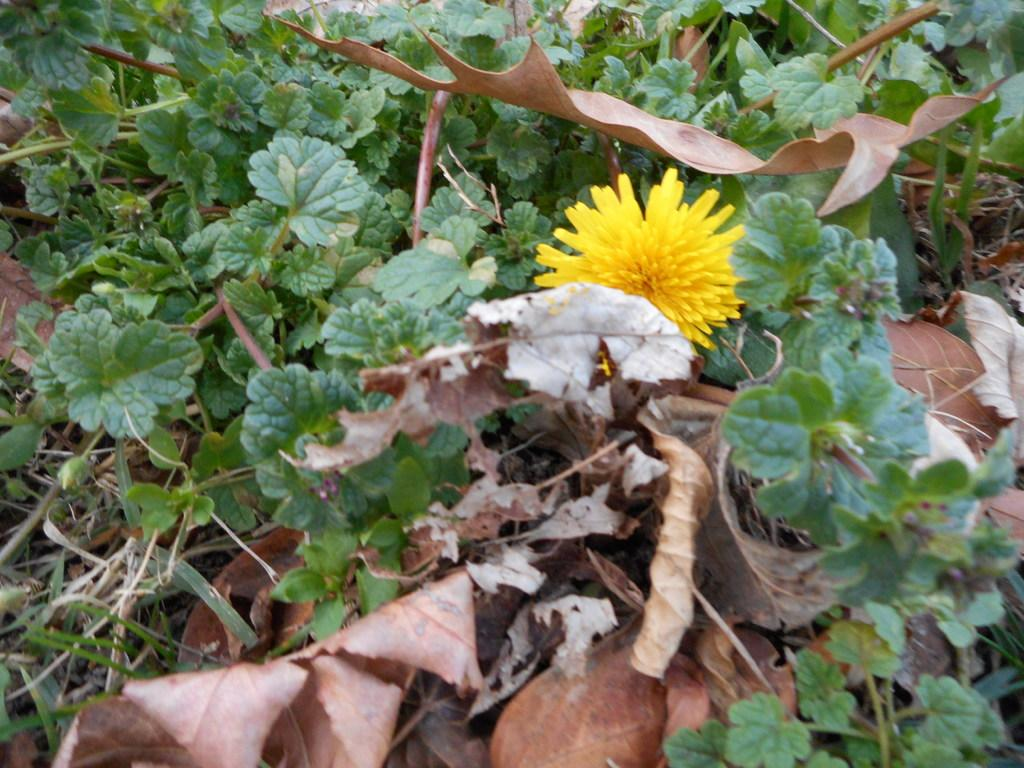What type of living organisms can be seen in the image? Plants can be seen in the image. What part of the plants is visible in the image? Leaves are present in the image. Is there any specific part of the plant that stands out in the image? Yes, there is a flower in the image. What type of knot can be seen in the image? There is no knot present in the image; it features plants, leaves, and a flower. What is the interest rate of the flower in the image? The image does not provide information about interest rates, as it focuses on plants, leaves, and a flower. 